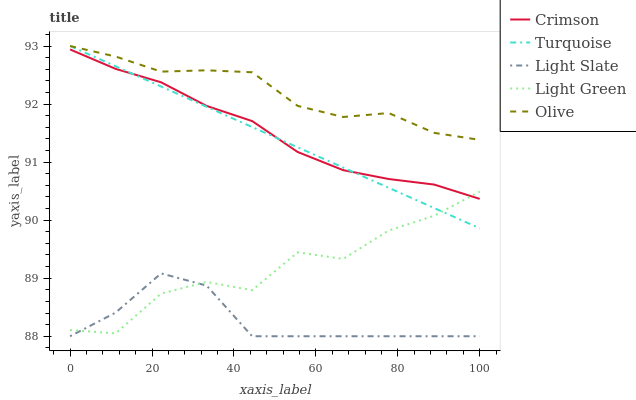Does Light Slate have the minimum area under the curve?
Answer yes or no. Yes. Does Olive have the maximum area under the curve?
Answer yes or no. Yes. Does Turquoise have the minimum area under the curve?
Answer yes or no. No. Does Turquoise have the maximum area under the curve?
Answer yes or no. No. Is Turquoise the smoothest?
Answer yes or no. Yes. Is Light Green the roughest?
Answer yes or no. Yes. Is Light Slate the smoothest?
Answer yes or no. No. Is Light Slate the roughest?
Answer yes or no. No. Does Light Slate have the lowest value?
Answer yes or no. Yes. Does Turquoise have the lowest value?
Answer yes or no. No. Does Olive have the highest value?
Answer yes or no. Yes. Does Light Slate have the highest value?
Answer yes or no. No. Is Light Green less than Olive?
Answer yes or no. Yes. Is Olive greater than Crimson?
Answer yes or no. Yes. Does Turquoise intersect Light Green?
Answer yes or no. Yes. Is Turquoise less than Light Green?
Answer yes or no. No. Is Turquoise greater than Light Green?
Answer yes or no. No. Does Light Green intersect Olive?
Answer yes or no. No. 